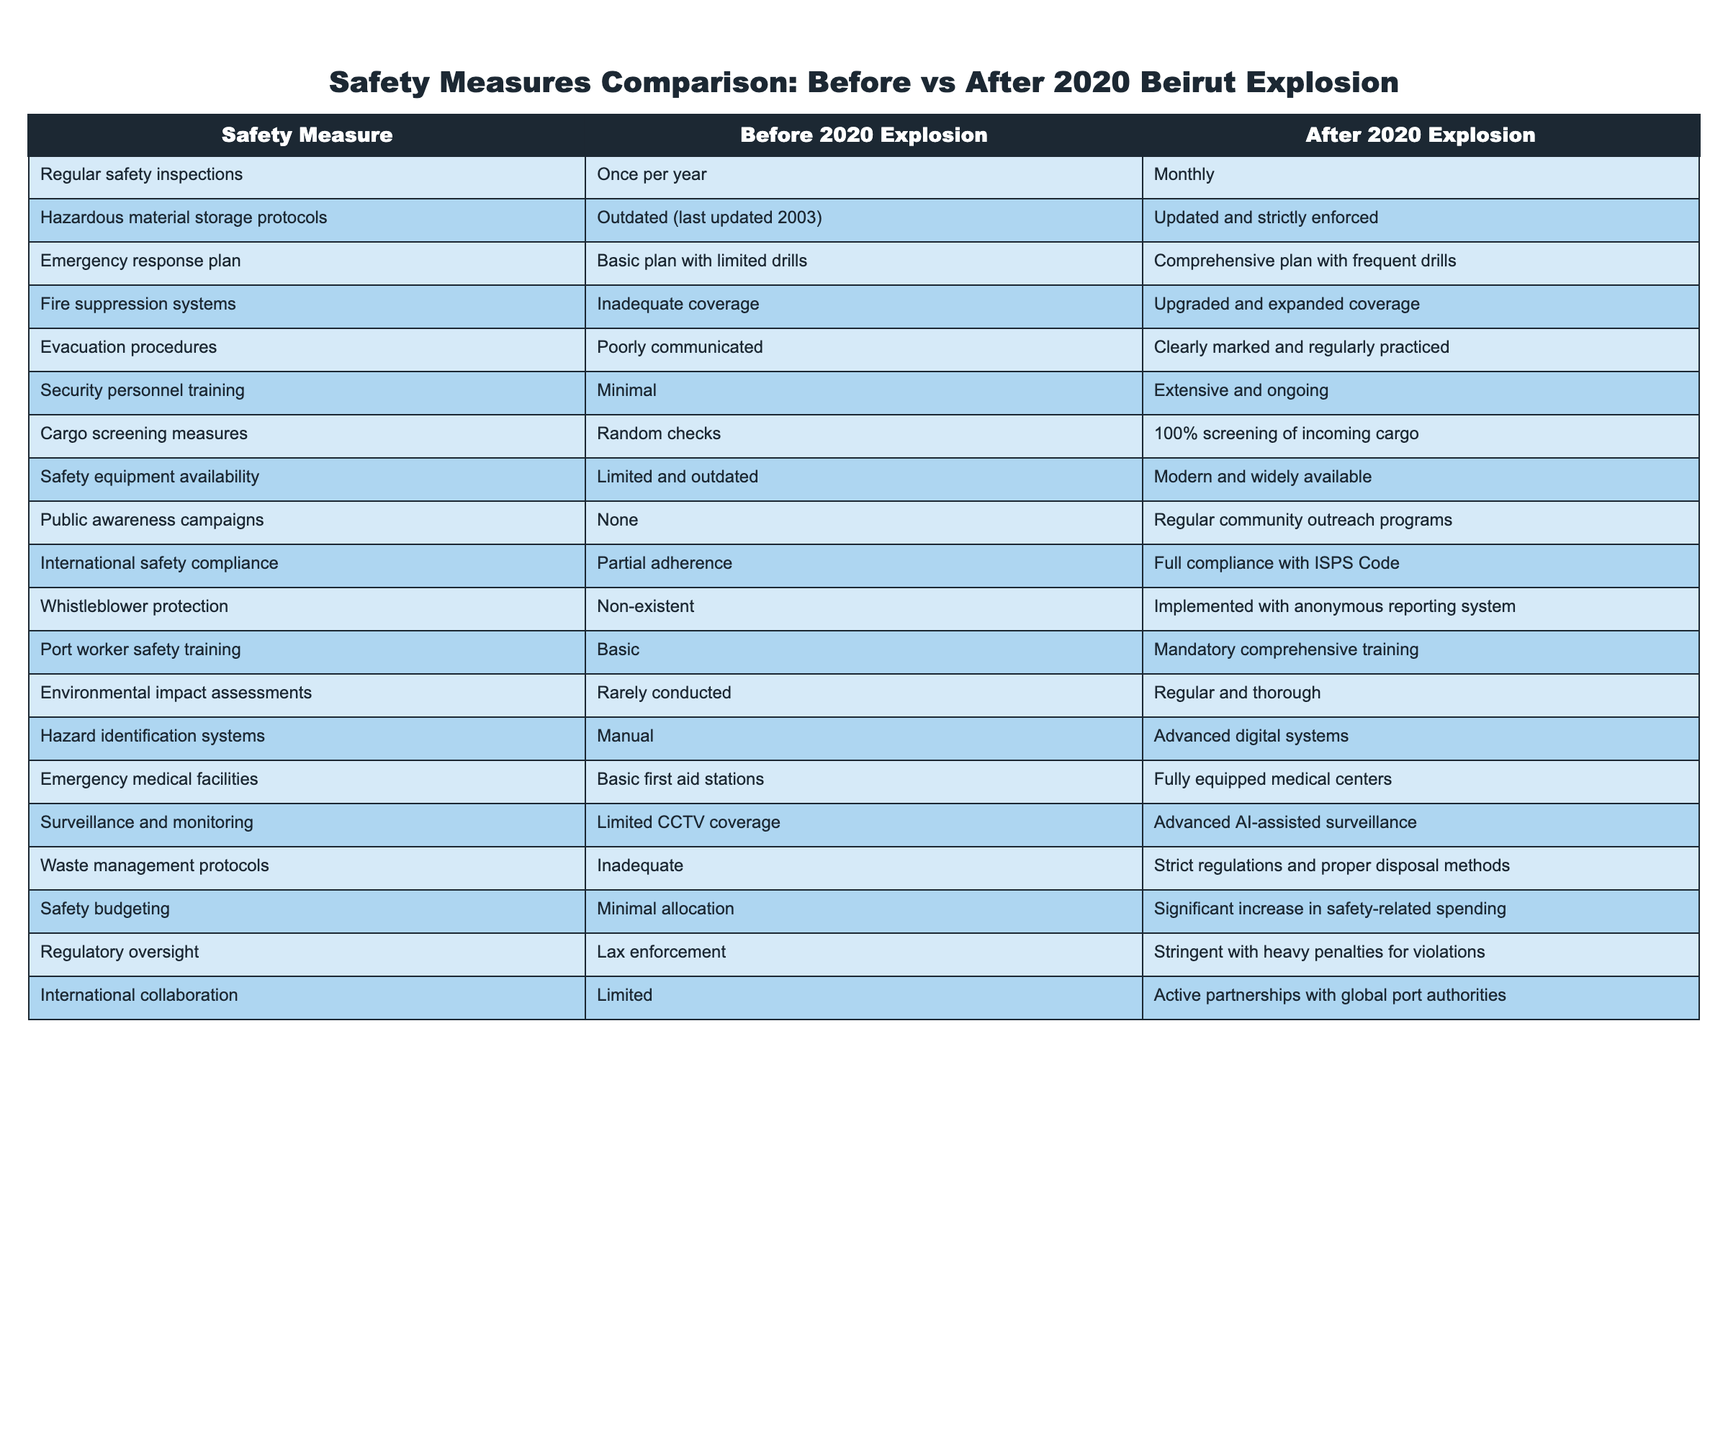What was the frequency of regular safety inspections before the 2020 explosion? The table indicates that regular safety inspections were conducted once per year before the explosion.
Answer: Once per year How did hazardous material storage protocols change after the 2020 explosion? According to the table, hazardous material storage protocols were outdated before the explosion but were updated and strictly enforced after it.
Answer: Updated and strictly enforced Is there a difference in the evacuation procedures before and after the explosion? Yes, the table shows that evacuation procedures were poorly communicated before the explosion and became clearly marked and regularly practiced afterward.
Answer: Yes What percentage increase in cargo screening measures occurred after the explosion? The table states that there were random checks before the explosion and 100% screening of incoming cargo afterward. Thus, the increase is from a low baseline (random checks) to full compliance, which is a significant increase.
Answer: Significant increase Did the availability of modern safety equipment increase after the explosion? Yes, the table indicates that safety equipment availability was limited and outdated before the explosion and became modern and widely available afterward.
Answer: Yes What is the difference in training for security personnel before and after the explosion? Before the explosion, training for security personnel was minimal, whereas it became extensive and ongoing after the explosion, indicating a strong improvement in training standards.
Answer: It improved significantly Were emergency medical facilities better equipped after the explosion? Yes, the table shows that emergency medical facilities were basic first aid stations before the explosion, which were upgraded to fully equipped medical centers afterward.
Answer: Yes How would you compare the level of international collaboration before and after the explosion? The table shows that international collaboration was limited before the explosion but became active partnerships with global port authorities afterward, indicating a vast improvement in cooperation.
Answer: Vast improvement What is the status of whistleblower protection measures before and after the explosion? The table reveals that whistleblower protection was non-existent before the explosion, while it was implemented with an anonymous reporting system after, reflecting a significant policy change.
Answer: Significant policy change 